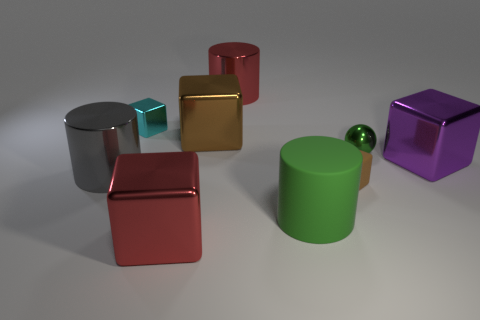Are there more large shiny things that are behind the big brown metal thing than tiny cyan things to the right of the big purple object?
Provide a succinct answer. Yes. The big metallic thing to the right of the brown matte thing is what color?
Keep it short and to the point. Purple. Do the small metallic thing that is on the right side of the red block and the small metal object behind the small green thing have the same shape?
Offer a very short reply. No. Are there any things of the same size as the rubber cylinder?
Make the answer very short. Yes. What material is the brown object to the left of the small brown thing?
Give a very brief answer. Metal. Are the red thing behind the purple metallic cube and the small brown cube made of the same material?
Ensure brevity in your answer.  No. Is there a tiny metal ball?
Ensure brevity in your answer.  Yes. What is the color of the other cylinder that is the same material as the gray cylinder?
Your response must be concise. Red. There is a small block that is in front of the metallic cylinder that is on the left side of the red thing that is behind the small cyan metallic cube; what color is it?
Ensure brevity in your answer.  Brown. There is a ball; is it the same size as the shiny cylinder to the right of the large brown metallic object?
Your response must be concise. No. 